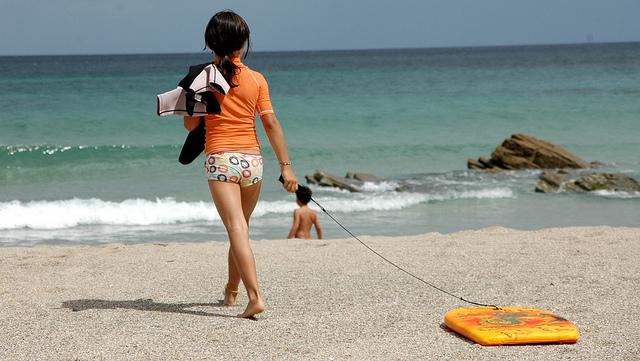What is the girl in the photo about to do?
Quick response, please. Surf. Is there litter on the beach?
Short answer required. No. How many surfaces are shown?
Answer briefly. 2. 